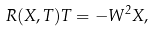Convert formula to latex. <formula><loc_0><loc_0><loc_500><loc_500>R ( X , T ) T = - W ^ { 2 } X ,</formula> 